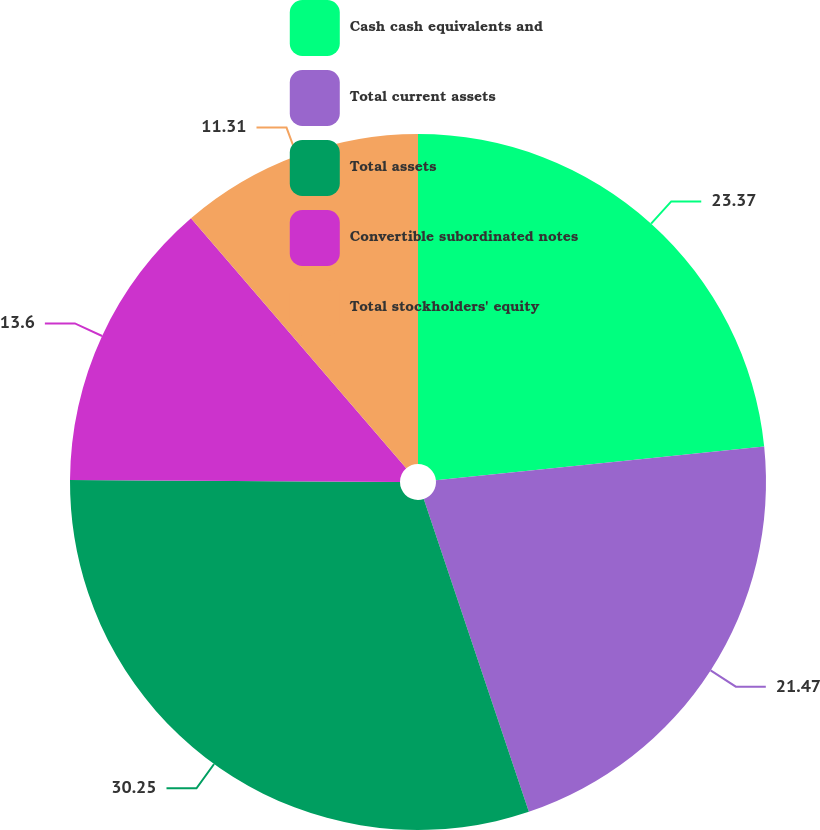<chart> <loc_0><loc_0><loc_500><loc_500><pie_chart><fcel>Cash cash equivalents and<fcel>Total current assets<fcel>Total assets<fcel>Convertible subordinated notes<fcel>Total stockholders' equity<nl><fcel>23.37%<fcel>21.47%<fcel>30.25%<fcel>13.6%<fcel>11.31%<nl></chart> 